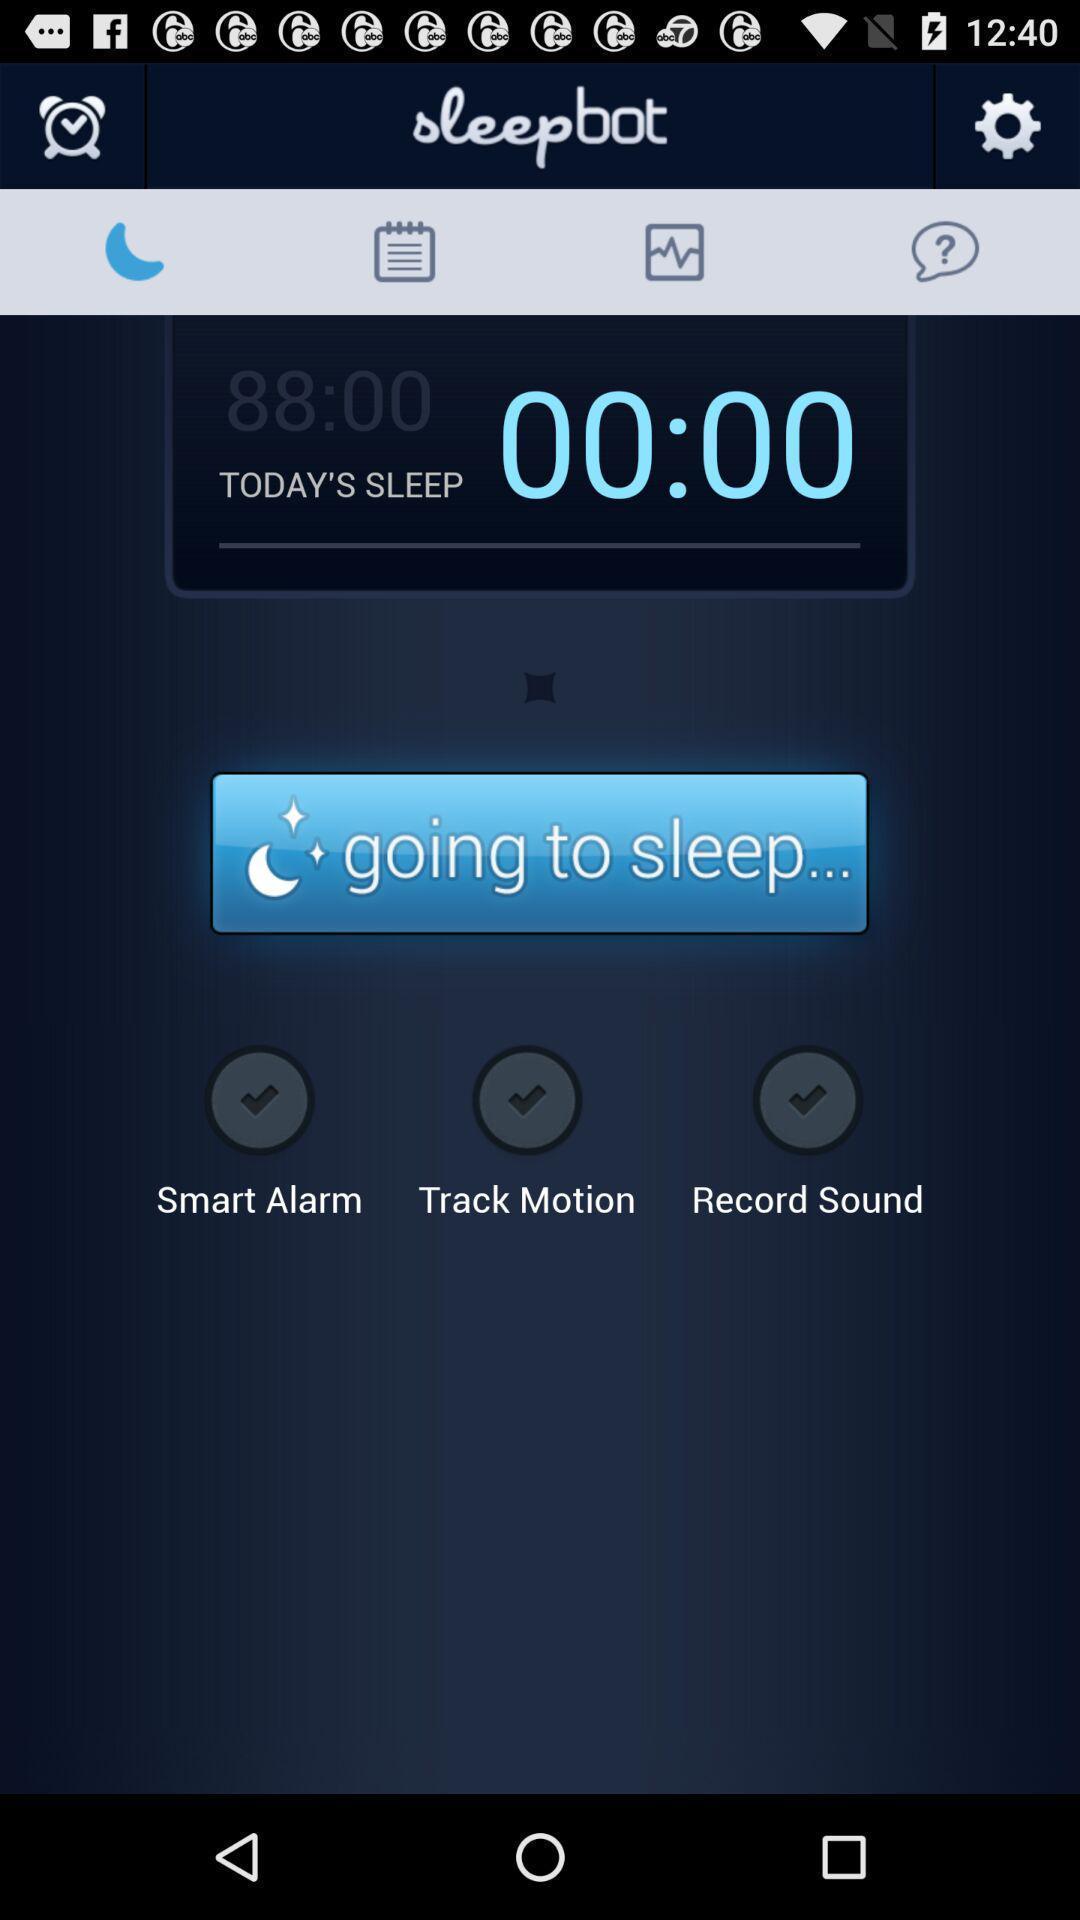Provide a textual representation of this image. Todays sleep timer showing in this page. 